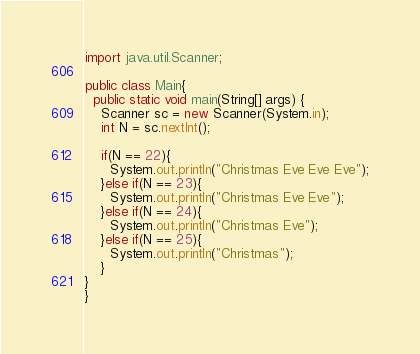<code> <loc_0><loc_0><loc_500><loc_500><_Java_>import java.util.Scanner;

public class Main{
  public static void main(String[] args) {
    Scanner sc = new Scanner(System.in);
    int N = sc.nextInt();

    if(N == 22){
      System.out.println("Christmas Eve Eve Eve");
    }else if(N == 23){
      System.out.println("Christmas Eve Eve");
    }else if(N == 24){
      System.out.println("Christmas Eve");
    }else if(N == 25){
      System.out.println("Christmas");
    }
}
}</code> 